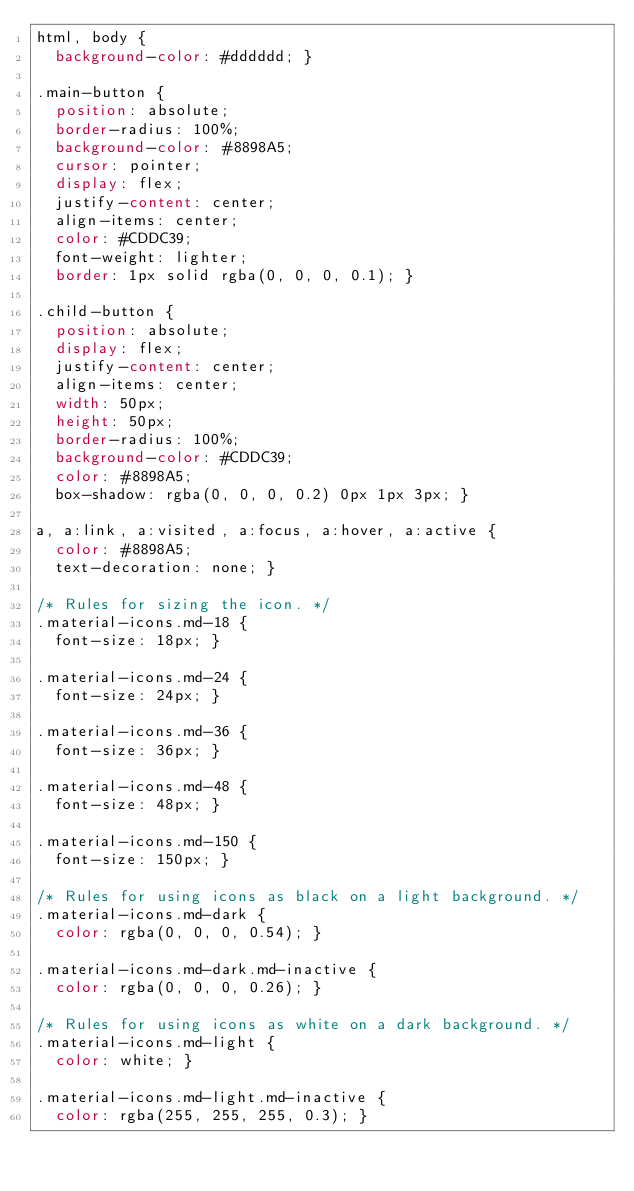<code> <loc_0><loc_0><loc_500><loc_500><_CSS_>html, body {
  background-color: #dddddd; }

.main-button {
  position: absolute;
  border-radius: 100%;
  background-color: #8898A5;
  cursor: pointer;
  display: flex;
  justify-content: center;
  align-items: center;
  color: #CDDC39;
  font-weight: lighter;
  border: 1px solid rgba(0, 0, 0, 0.1); }

.child-button {
  position: absolute;
  display: flex;
  justify-content: center;
  align-items: center;
  width: 50px;
  height: 50px;
  border-radius: 100%;
  background-color: #CDDC39;
  color: #8898A5;
  box-shadow: rgba(0, 0, 0, 0.2) 0px 1px 3px; }

a, a:link, a:visited, a:focus, a:hover, a:active {
  color: #8898A5;
  text-decoration: none; }

/* Rules for sizing the icon. */
.material-icons.md-18 {
  font-size: 18px; }

.material-icons.md-24 {
  font-size: 24px; }

.material-icons.md-36 {
  font-size: 36px; }

.material-icons.md-48 {
  font-size: 48px; }

.material-icons.md-150 {
  font-size: 150px; }

/* Rules for using icons as black on a light background. */
.material-icons.md-dark {
  color: rgba(0, 0, 0, 0.54); }

.material-icons.md-dark.md-inactive {
  color: rgba(0, 0, 0, 0.26); }

/* Rules for using icons as white on a dark background. */
.material-icons.md-light {
  color: white; }

.material-icons.md-light.md-inactive {
  color: rgba(255, 255, 255, 0.3); }

</code> 